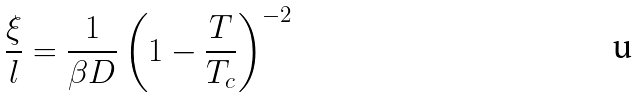Convert formula to latex. <formula><loc_0><loc_0><loc_500><loc_500>\frac { \xi } { l } = \frac { 1 } { \beta D } \left ( 1 - \frac { T } { T _ { c } } \right ) ^ { - 2 }</formula> 